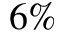<formula> <loc_0><loc_0><loc_500><loc_500>6 \%</formula> 